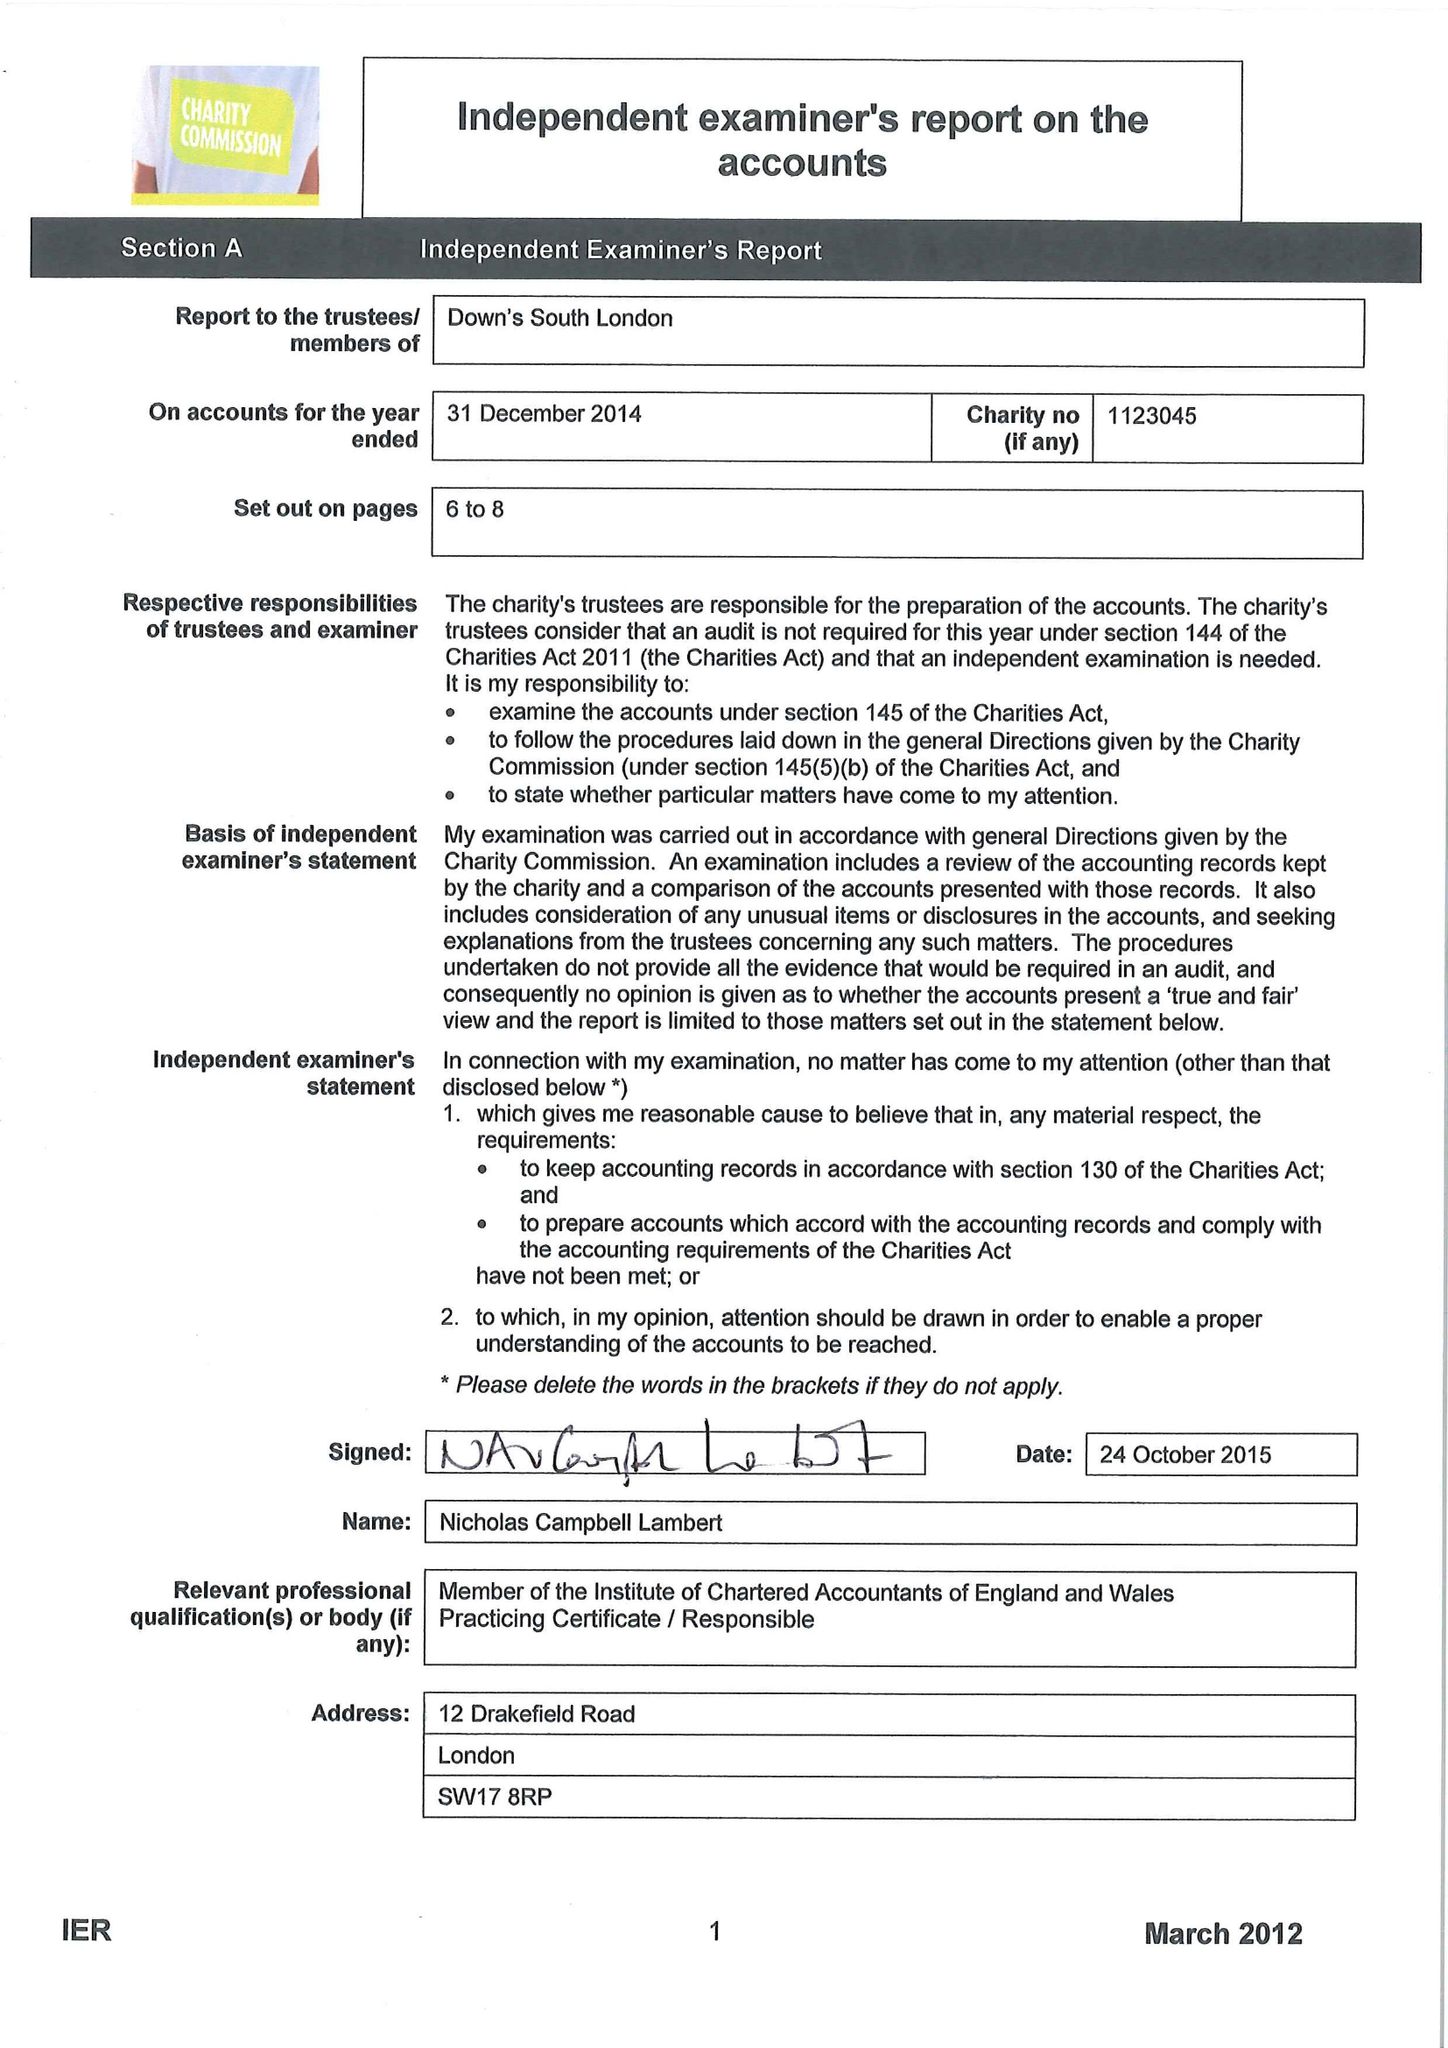What is the value for the spending_annually_in_british_pounds?
Answer the question using a single word or phrase. 77613.00 